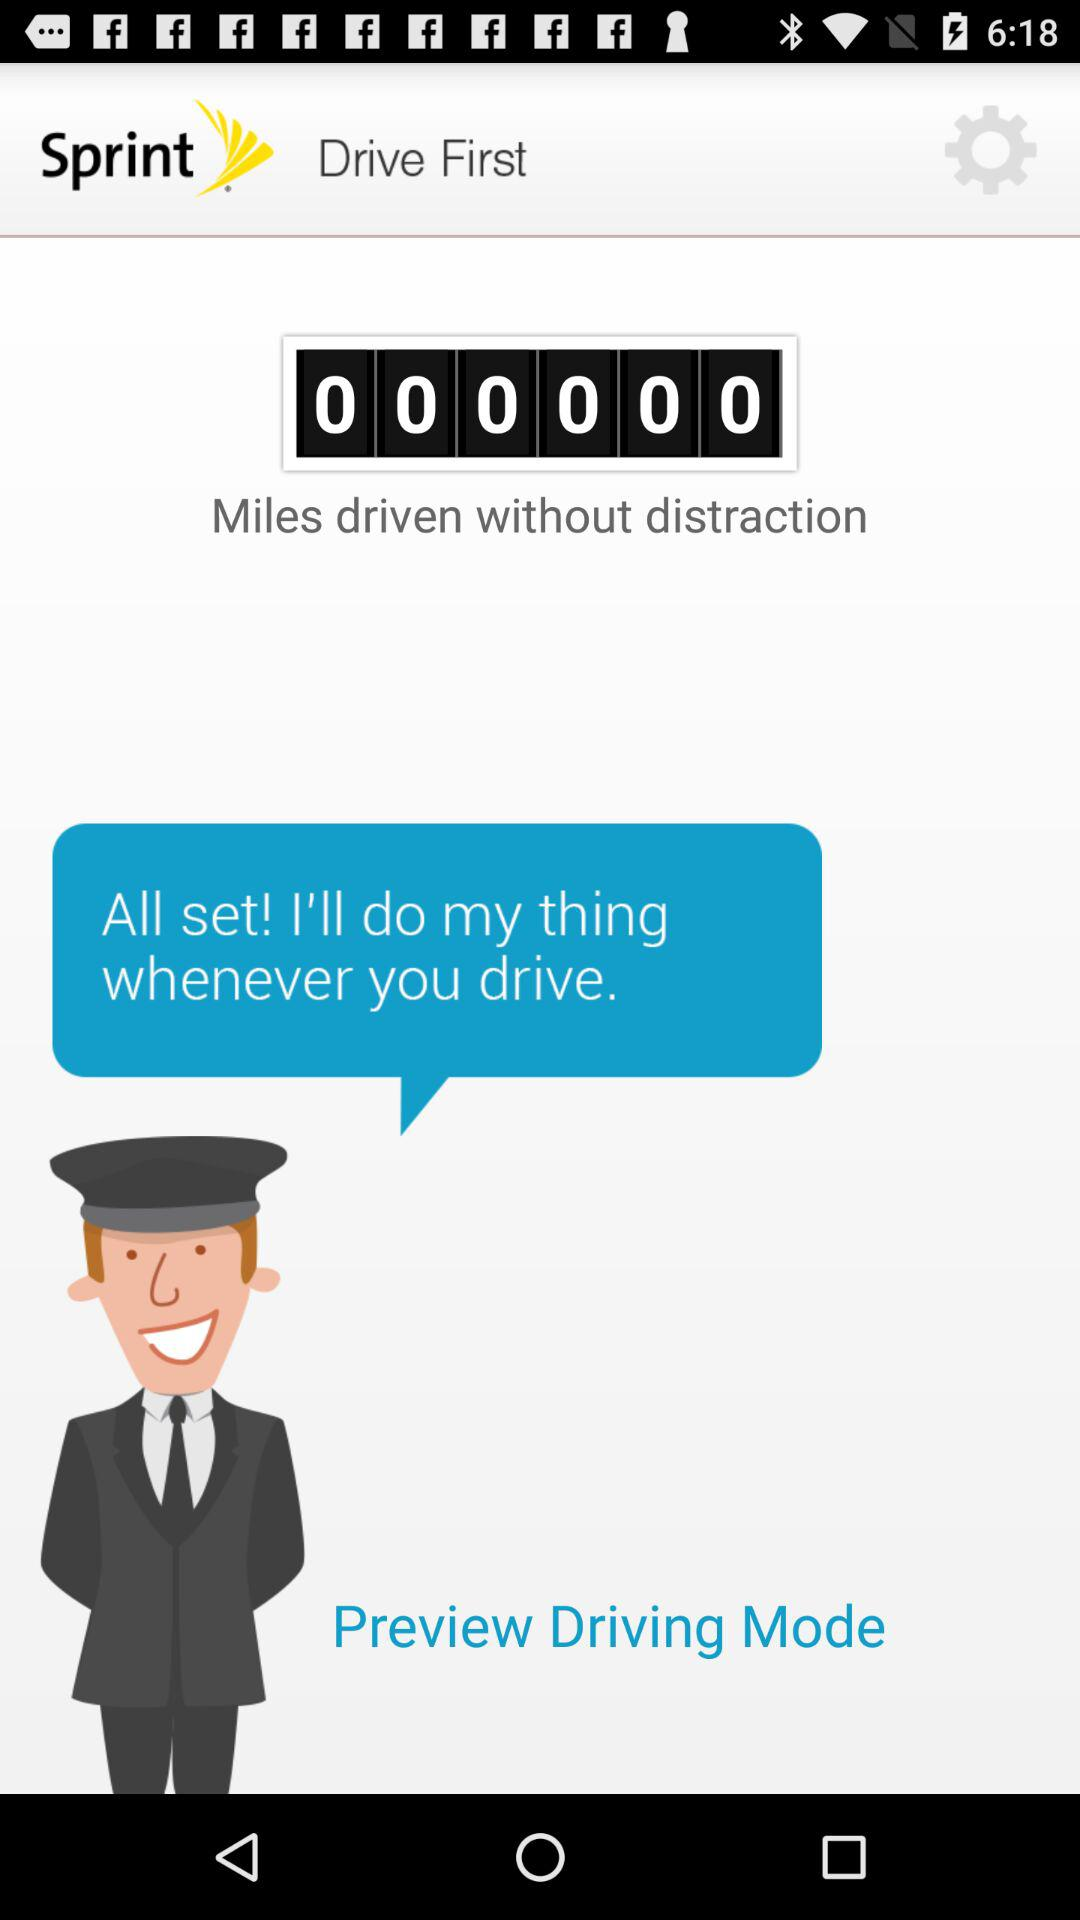How many miles are driven without distraction? The number of miles driven without distraction is 0. 